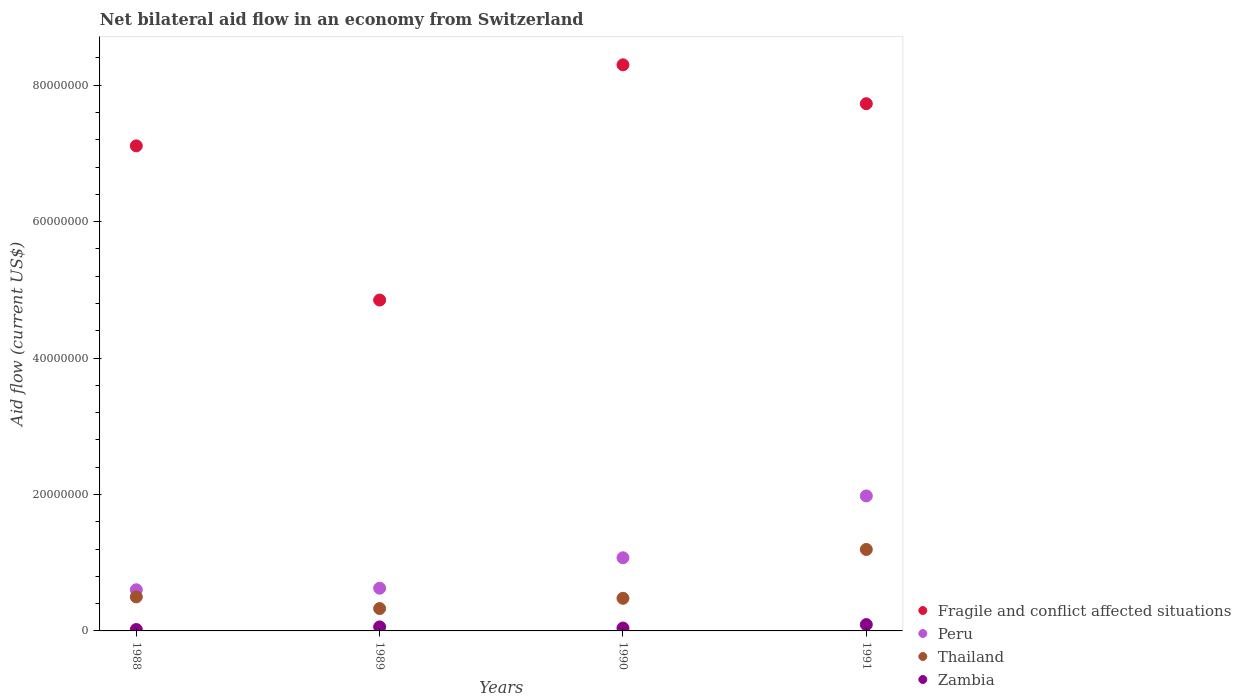Is the number of dotlines equal to the number of legend labels?
Your answer should be very brief. Yes. What is the net bilateral aid flow in Zambia in 1990?
Provide a short and direct response. 4.20e+05. Across all years, what is the maximum net bilateral aid flow in Peru?
Give a very brief answer. 1.98e+07. In which year was the net bilateral aid flow in Fragile and conflict affected situations maximum?
Your answer should be very brief. 1990. In which year was the net bilateral aid flow in Zambia minimum?
Offer a terse response. 1988. What is the total net bilateral aid flow in Zambia in the graph?
Provide a short and direct response. 2.15e+06. What is the difference between the net bilateral aid flow in Zambia in 1988 and that in 1989?
Provide a succinct answer. -3.80e+05. What is the difference between the net bilateral aid flow in Fragile and conflict affected situations in 1989 and the net bilateral aid flow in Zambia in 1990?
Keep it short and to the point. 4.81e+07. What is the average net bilateral aid flow in Thailand per year?
Give a very brief answer. 6.25e+06. In the year 1990, what is the difference between the net bilateral aid flow in Fragile and conflict affected situations and net bilateral aid flow in Thailand?
Make the answer very short. 7.82e+07. What is the ratio of the net bilateral aid flow in Fragile and conflict affected situations in 1989 to that in 1991?
Give a very brief answer. 0.63. Is the net bilateral aid flow in Peru in 1988 less than that in 1991?
Your response must be concise. Yes. What is the difference between the highest and the lowest net bilateral aid flow in Fragile and conflict affected situations?
Provide a succinct answer. 3.45e+07. Is the sum of the net bilateral aid flow in Zambia in 1989 and 1991 greater than the maximum net bilateral aid flow in Peru across all years?
Your answer should be very brief. No. Is it the case that in every year, the sum of the net bilateral aid flow in Zambia and net bilateral aid flow in Thailand  is greater than the net bilateral aid flow in Fragile and conflict affected situations?
Your answer should be compact. No. Is the net bilateral aid flow in Thailand strictly less than the net bilateral aid flow in Peru over the years?
Keep it short and to the point. Yes. How many dotlines are there?
Provide a short and direct response. 4. Are the values on the major ticks of Y-axis written in scientific E-notation?
Make the answer very short. No. Does the graph contain grids?
Keep it short and to the point. No. How many legend labels are there?
Your response must be concise. 4. What is the title of the graph?
Provide a short and direct response. Net bilateral aid flow in an economy from Switzerland. Does "Russian Federation" appear as one of the legend labels in the graph?
Provide a succinct answer. No. What is the label or title of the X-axis?
Make the answer very short. Years. What is the Aid flow (current US$) of Fragile and conflict affected situations in 1988?
Your response must be concise. 7.11e+07. What is the Aid flow (current US$) in Peru in 1988?
Your answer should be compact. 6.03e+06. What is the Aid flow (current US$) in Thailand in 1988?
Your answer should be very brief. 4.99e+06. What is the Aid flow (current US$) in Fragile and conflict affected situations in 1989?
Make the answer very short. 4.85e+07. What is the Aid flow (current US$) in Peru in 1989?
Make the answer very short. 6.26e+06. What is the Aid flow (current US$) of Thailand in 1989?
Ensure brevity in your answer.  3.28e+06. What is the Aid flow (current US$) in Zambia in 1989?
Provide a short and direct response. 5.90e+05. What is the Aid flow (current US$) of Fragile and conflict affected situations in 1990?
Provide a short and direct response. 8.30e+07. What is the Aid flow (current US$) of Peru in 1990?
Ensure brevity in your answer.  1.07e+07. What is the Aid flow (current US$) in Thailand in 1990?
Your answer should be very brief. 4.78e+06. What is the Aid flow (current US$) in Zambia in 1990?
Your response must be concise. 4.20e+05. What is the Aid flow (current US$) in Fragile and conflict affected situations in 1991?
Provide a succinct answer. 7.73e+07. What is the Aid flow (current US$) in Peru in 1991?
Give a very brief answer. 1.98e+07. What is the Aid flow (current US$) in Thailand in 1991?
Offer a very short reply. 1.19e+07. What is the Aid flow (current US$) in Zambia in 1991?
Offer a very short reply. 9.30e+05. Across all years, what is the maximum Aid flow (current US$) in Fragile and conflict affected situations?
Offer a very short reply. 8.30e+07. Across all years, what is the maximum Aid flow (current US$) of Peru?
Offer a terse response. 1.98e+07. Across all years, what is the maximum Aid flow (current US$) in Thailand?
Offer a terse response. 1.19e+07. Across all years, what is the maximum Aid flow (current US$) in Zambia?
Your answer should be very brief. 9.30e+05. Across all years, what is the minimum Aid flow (current US$) in Fragile and conflict affected situations?
Offer a terse response. 4.85e+07. Across all years, what is the minimum Aid flow (current US$) in Peru?
Your response must be concise. 6.03e+06. Across all years, what is the minimum Aid flow (current US$) of Thailand?
Offer a terse response. 3.28e+06. What is the total Aid flow (current US$) in Fragile and conflict affected situations in the graph?
Your response must be concise. 2.80e+08. What is the total Aid flow (current US$) in Peru in the graph?
Your answer should be very brief. 4.28e+07. What is the total Aid flow (current US$) in Thailand in the graph?
Make the answer very short. 2.50e+07. What is the total Aid flow (current US$) in Zambia in the graph?
Provide a succinct answer. 2.15e+06. What is the difference between the Aid flow (current US$) in Fragile and conflict affected situations in 1988 and that in 1989?
Your answer should be compact. 2.26e+07. What is the difference between the Aid flow (current US$) in Thailand in 1988 and that in 1989?
Offer a terse response. 1.71e+06. What is the difference between the Aid flow (current US$) of Zambia in 1988 and that in 1989?
Offer a very short reply. -3.80e+05. What is the difference between the Aid flow (current US$) in Fragile and conflict affected situations in 1988 and that in 1990?
Ensure brevity in your answer.  -1.19e+07. What is the difference between the Aid flow (current US$) in Peru in 1988 and that in 1990?
Your response must be concise. -4.69e+06. What is the difference between the Aid flow (current US$) in Thailand in 1988 and that in 1990?
Provide a short and direct response. 2.10e+05. What is the difference between the Aid flow (current US$) in Fragile and conflict affected situations in 1988 and that in 1991?
Your response must be concise. -6.18e+06. What is the difference between the Aid flow (current US$) of Peru in 1988 and that in 1991?
Keep it short and to the point. -1.38e+07. What is the difference between the Aid flow (current US$) of Thailand in 1988 and that in 1991?
Provide a short and direct response. -6.95e+06. What is the difference between the Aid flow (current US$) of Zambia in 1988 and that in 1991?
Give a very brief answer. -7.20e+05. What is the difference between the Aid flow (current US$) of Fragile and conflict affected situations in 1989 and that in 1990?
Your response must be concise. -3.45e+07. What is the difference between the Aid flow (current US$) of Peru in 1989 and that in 1990?
Provide a succinct answer. -4.46e+06. What is the difference between the Aid flow (current US$) in Thailand in 1989 and that in 1990?
Your answer should be compact. -1.50e+06. What is the difference between the Aid flow (current US$) of Zambia in 1989 and that in 1990?
Your answer should be compact. 1.70e+05. What is the difference between the Aid flow (current US$) in Fragile and conflict affected situations in 1989 and that in 1991?
Your answer should be very brief. -2.88e+07. What is the difference between the Aid flow (current US$) of Peru in 1989 and that in 1991?
Your response must be concise. -1.35e+07. What is the difference between the Aid flow (current US$) of Thailand in 1989 and that in 1991?
Ensure brevity in your answer.  -8.66e+06. What is the difference between the Aid flow (current US$) of Fragile and conflict affected situations in 1990 and that in 1991?
Ensure brevity in your answer.  5.70e+06. What is the difference between the Aid flow (current US$) in Peru in 1990 and that in 1991?
Offer a terse response. -9.07e+06. What is the difference between the Aid flow (current US$) of Thailand in 1990 and that in 1991?
Provide a short and direct response. -7.16e+06. What is the difference between the Aid flow (current US$) in Zambia in 1990 and that in 1991?
Ensure brevity in your answer.  -5.10e+05. What is the difference between the Aid flow (current US$) in Fragile and conflict affected situations in 1988 and the Aid flow (current US$) in Peru in 1989?
Your answer should be compact. 6.48e+07. What is the difference between the Aid flow (current US$) in Fragile and conflict affected situations in 1988 and the Aid flow (current US$) in Thailand in 1989?
Your response must be concise. 6.78e+07. What is the difference between the Aid flow (current US$) in Fragile and conflict affected situations in 1988 and the Aid flow (current US$) in Zambia in 1989?
Offer a very short reply. 7.05e+07. What is the difference between the Aid flow (current US$) of Peru in 1988 and the Aid flow (current US$) of Thailand in 1989?
Provide a succinct answer. 2.75e+06. What is the difference between the Aid flow (current US$) of Peru in 1988 and the Aid flow (current US$) of Zambia in 1989?
Provide a short and direct response. 5.44e+06. What is the difference between the Aid flow (current US$) in Thailand in 1988 and the Aid flow (current US$) in Zambia in 1989?
Keep it short and to the point. 4.40e+06. What is the difference between the Aid flow (current US$) of Fragile and conflict affected situations in 1988 and the Aid flow (current US$) of Peru in 1990?
Your answer should be compact. 6.04e+07. What is the difference between the Aid flow (current US$) in Fragile and conflict affected situations in 1988 and the Aid flow (current US$) in Thailand in 1990?
Offer a very short reply. 6.63e+07. What is the difference between the Aid flow (current US$) in Fragile and conflict affected situations in 1988 and the Aid flow (current US$) in Zambia in 1990?
Give a very brief answer. 7.07e+07. What is the difference between the Aid flow (current US$) in Peru in 1988 and the Aid flow (current US$) in Thailand in 1990?
Your answer should be very brief. 1.25e+06. What is the difference between the Aid flow (current US$) in Peru in 1988 and the Aid flow (current US$) in Zambia in 1990?
Make the answer very short. 5.61e+06. What is the difference between the Aid flow (current US$) of Thailand in 1988 and the Aid flow (current US$) of Zambia in 1990?
Offer a terse response. 4.57e+06. What is the difference between the Aid flow (current US$) of Fragile and conflict affected situations in 1988 and the Aid flow (current US$) of Peru in 1991?
Your answer should be compact. 5.13e+07. What is the difference between the Aid flow (current US$) in Fragile and conflict affected situations in 1988 and the Aid flow (current US$) in Thailand in 1991?
Provide a short and direct response. 5.92e+07. What is the difference between the Aid flow (current US$) in Fragile and conflict affected situations in 1988 and the Aid flow (current US$) in Zambia in 1991?
Your response must be concise. 7.02e+07. What is the difference between the Aid flow (current US$) of Peru in 1988 and the Aid flow (current US$) of Thailand in 1991?
Offer a very short reply. -5.91e+06. What is the difference between the Aid flow (current US$) in Peru in 1988 and the Aid flow (current US$) in Zambia in 1991?
Your answer should be compact. 5.10e+06. What is the difference between the Aid flow (current US$) of Thailand in 1988 and the Aid flow (current US$) of Zambia in 1991?
Your response must be concise. 4.06e+06. What is the difference between the Aid flow (current US$) in Fragile and conflict affected situations in 1989 and the Aid flow (current US$) in Peru in 1990?
Offer a very short reply. 3.78e+07. What is the difference between the Aid flow (current US$) in Fragile and conflict affected situations in 1989 and the Aid flow (current US$) in Thailand in 1990?
Keep it short and to the point. 4.37e+07. What is the difference between the Aid flow (current US$) of Fragile and conflict affected situations in 1989 and the Aid flow (current US$) of Zambia in 1990?
Your answer should be very brief. 4.81e+07. What is the difference between the Aid flow (current US$) of Peru in 1989 and the Aid flow (current US$) of Thailand in 1990?
Your response must be concise. 1.48e+06. What is the difference between the Aid flow (current US$) in Peru in 1989 and the Aid flow (current US$) in Zambia in 1990?
Offer a very short reply. 5.84e+06. What is the difference between the Aid flow (current US$) in Thailand in 1989 and the Aid flow (current US$) in Zambia in 1990?
Provide a short and direct response. 2.86e+06. What is the difference between the Aid flow (current US$) in Fragile and conflict affected situations in 1989 and the Aid flow (current US$) in Peru in 1991?
Your response must be concise. 2.87e+07. What is the difference between the Aid flow (current US$) of Fragile and conflict affected situations in 1989 and the Aid flow (current US$) of Thailand in 1991?
Give a very brief answer. 3.66e+07. What is the difference between the Aid flow (current US$) in Fragile and conflict affected situations in 1989 and the Aid flow (current US$) in Zambia in 1991?
Offer a terse response. 4.76e+07. What is the difference between the Aid flow (current US$) in Peru in 1989 and the Aid flow (current US$) in Thailand in 1991?
Offer a very short reply. -5.68e+06. What is the difference between the Aid flow (current US$) of Peru in 1989 and the Aid flow (current US$) of Zambia in 1991?
Give a very brief answer. 5.33e+06. What is the difference between the Aid flow (current US$) of Thailand in 1989 and the Aid flow (current US$) of Zambia in 1991?
Your answer should be very brief. 2.35e+06. What is the difference between the Aid flow (current US$) in Fragile and conflict affected situations in 1990 and the Aid flow (current US$) in Peru in 1991?
Your response must be concise. 6.32e+07. What is the difference between the Aid flow (current US$) of Fragile and conflict affected situations in 1990 and the Aid flow (current US$) of Thailand in 1991?
Make the answer very short. 7.10e+07. What is the difference between the Aid flow (current US$) of Fragile and conflict affected situations in 1990 and the Aid flow (current US$) of Zambia in 1991?
Offer a terse response. 8.20e+07. What is the difference between the Aid flow (current US$) of Peru in 1990 and the Aid flow (current US$) of Thailand in 1991?
Your response must be concise. -1.22e+06. What is the difference between the Aid flow (current US$) in Peru in 1990 and the Aid flow (current US$) in Zambia in 1991?
Offer a very short reply. 9.79e+06. What is the difference between the Aid flow (current US$) in Thailand in 1990 and the Aid flow (current US$) in Zambia in 1991?
Your answer should be very brief. 3.85e+06. What is the average Aid flow (current US$) of Fragile and conflict affected situations per year?
Offer a very short reply. 7.00e+07. What is the average Aid flow (current US$) of Peru per year?
Give a very brief answer. 1.07e+07. What is the average Aid flow (current US$) of Thailand per year?
Your answer should be compact. 6.25e+06. What is the average Aid flow (current US$) of Zambia per year?
Give a very brief answer. 5.38e+05. In the year 1988, what is the difference between the Aid flow (current US$) in Fragile and conflict affected situations and Aid flow (current US$) in Peru?
Your answer should be very brief. 6.51e+07. In the year 1988, what is the difference between the Aid flow (current US$) of Fragile and conflict affected situations and Aid flow (current US$) of Thailand?
Your answer should be very brief. 6.61e+07. In the year 1988, what is the difference between the Aid flow (current US$) of Fragile and conflict affected situations and Aid flow (current US$) of Zambia?
Make the answer very short. 7.09e+07. In the year 1988, what is the difference between the Aid flow (current US$) in Peru and Aid flow (current US$) in Thailand?
Provide a succinct answer. 1.04e+06. In the year 1988, what is the difference between the Aid flow (current US$) of Peru and Aid flow (current US$) of Zambia?
Give a very brief answer. 5.82e+06. In the year 1988, what is the difference between the Aid flow (current US$) of Thailand and Aid flow (current US$) of Zambia?
Make the answer very short. 4.78e+06. In the year 1989, what is the difference between the Aid flow (current US$) of Fragile and conflict affected situations and Aid flow (current US$) of Peru?
Provide a succinct answer. 4.22e+07. In the year 1989, what is the difference between the Aid flow (current US$) of Fragile and conflict affected situations and Aid flow (current US$) of Thailand?
Give a very brief answer. 4.52e+07. In the year 1989, what is the difference between the Aid flow (current US$) of Fragile and conflict affected situations and Aid flow (current US$) of Zambia?
Provide a short and direct response. 4.79e+07. In the year 1989, what is the difference between the Aid flow (current US$) in Peru and Aid flow (current US$) in Thailand?
Provide a succinct answer. 2.98e+06. In the year 1989, what is the difference between the Aid flow (current US$) in Peru and Aid flow (current US$) in Zambia?
Provide a short and direct response. 5.67e+06. In the year 1989, what is the difference between the Aid flow (current US$) of Thailand and Aid flow (current US$) of Zambia?
Provide a succinct answer. 2.69e+06. In the year 1990, what is the difference between the Aid flow (current US$) in Fragile and conflict affected situations and Aid flow (current US$) in Peru?
Your response must be concise. 7.23e+07. In the year 1990, what is the difference between the Aid flow (current US$) of Fragile and conflict affected situations and Aid flow (current US$) of Thailand?
Offer a terse response. 7.82e+07. In the year 1990, what is the difference between the Aid flow (current US$) in Fragile and conflict affected situations and Aid flow (current US$) in Zambia?
Provide a short and direct response. 8.26e+07. In the year 1990, what is the difference between the Aid flow (current US$) of Peru and Aid flow (current US$) of Thailand?
Offer a terse response. 5.94e+06. In the year 1990, what is the difference between the Aid flow (current US$) of Peru and Aid flow (current US$) of Zambia?
Make the answer very short. 1.03e+07. In the year 1990, what is the difference between the Aid flow (current US$) in Thailand and Aid flow (current US$) in Zambia?
Offer a terse response. 4.36e+06. In the year 1991, what is the difference between the Aid flow (current US$) in Fragile and conflict affected situations and Aid flow (current US$) in Peru?
Your response must be concise. 5.75e+07. In the year 1991, what is the difference between the Aid flow (current US$) of Fragile and conflict affected situations and Aid flow (current US$) of Thailand?
Make the answer very short. 6.53e+07. In the year 1991, what is the difference between the Aid flow (current US$) in Fragile and conflict affected situations and Aid flow (current US$) in Zambia?
Give a very brief answer. 7.64e+07. In the year 1991, what is the difference between the Aid flow (current US$) of Peru and Aid flow (current US$) of Thailand?
Offer a terse response. 7.85e+06. In the year 1991, what is the difference between the Aid flow (current US$) of Peru and Aid flow (current US$) of Zambia?
Your answer should be compact. 1.89e+07. In the year 1991, what is the difference between the Aid flow (current US$) of Thailand and Aid flow (current US$) of Zambia?
Offer a terse response. 1.10e+07. What is the ratio of the Aid flow (current US$) of Fragile and conflict affected situations in 1988 to that in 1989?
Make the answer very short. 1.47. What is the ratio of the Aid flow (current US$) in Peru in 1988 to that in 1989?
Your answer should be compact. 0.96. What is the ratio of the Aid flow (current US$) of Thailand in 1988 to that in 1989?
Keep it short and to the point. 1.52. What is the ratio of the Aid flow (current US$) in Zambia in 1988 to that in 1989?
Your answer should be compact. 0.36. What is the ratio of the Aid flow (current US$) in Fragile and conflict affected situations in 1988 to that in 1990?
Provide a short and direct response. 0.86. What is the ratio of the Aid flow (current US$) of Peru in 1988 to that in 1990?
Offer a terse response. 0.56. What is the ratio of the Aid flow (current US$) in Thailand in 1988 to that in 1990?
Ensure brevity in your answer.  1.04. What is the ratio of the Aid flow (current US$) of Fragile and conflict affected situations in 1988 to that in 1991?
Keep it short and to the point. 0.92. What is the ratio of the Aid flow (current US$) in Peru in 1988 to that in 1991?
Provide a succinct answer. 0.3. What is the ratio of the Aid flow (current US$) in Thailand in 1988 to that in 1991?
Give a very brief answer. 0.42. What is the ratio of the Aid flow (current US$) in Zambia in 1988 to that in 1991?
Your answer should be very brief. 0.23. What is the ratio of the Aid flow (current US$) in Fragile and conflict affected situations in 1989 to that in 1990?
Give a very brief answer. 0.58. What is the ratio of the Aid flow (current US$) in Peru in 1989 to that in 1990?
Keep it short and to the point. 0.58. What is the ratio of the Aid flow (current US$) in Thailand in 1989 to that in 1990?
Provide a succinct answer. 0.69. What is the ratio of the Aid flow (current US$) in Zambia in 1989 to that in 1990?
Offer a terse response. 1.4. What is the ratio of the Aid flow (current US$) of Fragile and conflict affected situations in 1989 to that in 1991?
Provide a succinct answer. 0.63. What is the ratio of the Aid flow (current US$) in Peru in 1989 to that in 1991?
Make the answer very short. 0.32. What is the ratio of the Aid flow (current US$) in Thailand in 1989 to that in 1991?
Provide a succinct answer. 0.27. What is the ratio of the Aid flow (current US$) in Zambia in 1989 to that in 1991?
Give a very brief answer. 0.63. What is the ratio of the Aid flow (current US$) in Fragile and conflict affected situations in 1990 to that in 1991?
Offer a terse response. 1.07. What is the ratio of the Aid flow (current US$) of Peru in 1990 to that in 1991?
Offer a terse response. 0.54. What is the ratio of the Aid flow (current US$) in Thailand in 1990 to that in 1991?
Offer a very short reply. 0.4. What is the ratio of the Aid flow (current US$) of Zambia in 1990 to that in 1991?
Ensure brevity in your answer.  0.45. What is the difference between the highest and the second highest Aid flow (current US$) in Fragile and conflict affected situations?
Make the answer very short. 5.70e+06. What is the difference between the highest and the second highest Aid flow (current US$) of Peru?
Your answer should be very brief. 9.07e+06. What is the difference between the highest and the second highest Aid flow (current US$) in Thailand?
Give a very brief answer. 6.95e+06. What is the difference between the highest and the second highest Aid flow (current US$) in Zambia?
Provide a short and direct response. 3.40e+05. What is the difference between the highest and the lowest Aid flow (current US$) of Fragile and conflict affected situations?
Offer a terse response. 3.45e+07. What is the difference between the highest and the lowest Aid flow (current US$) of Peru?
Your answer should be compact. 1.38e+07. What is the difference between the highest and the lowest Aid flow (current US$) of Thailand?
Your answer should be compact. 8.66e+06. What is the difference between the highest and the lowest Aid flow (current US$) in Zambia?
Give a very brief answer. 7.20e+05. 